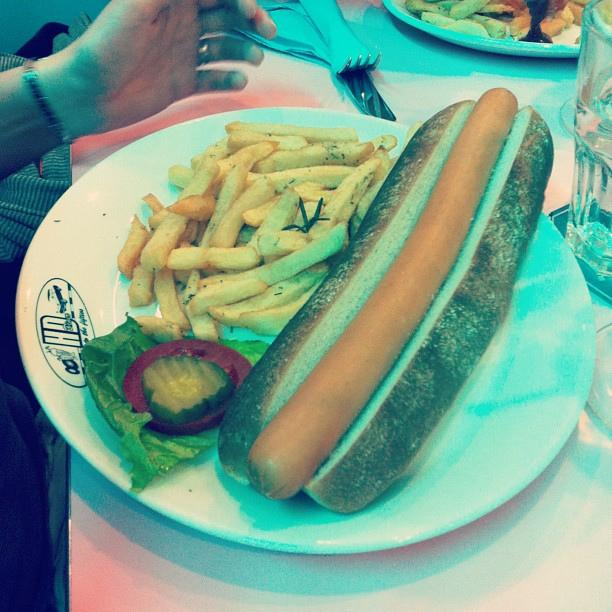Why might this longest food be unappealing to some?

Choices:
A) lacks condiments
B) uncooked
C) too hot
D) to spicy lacks condiments 